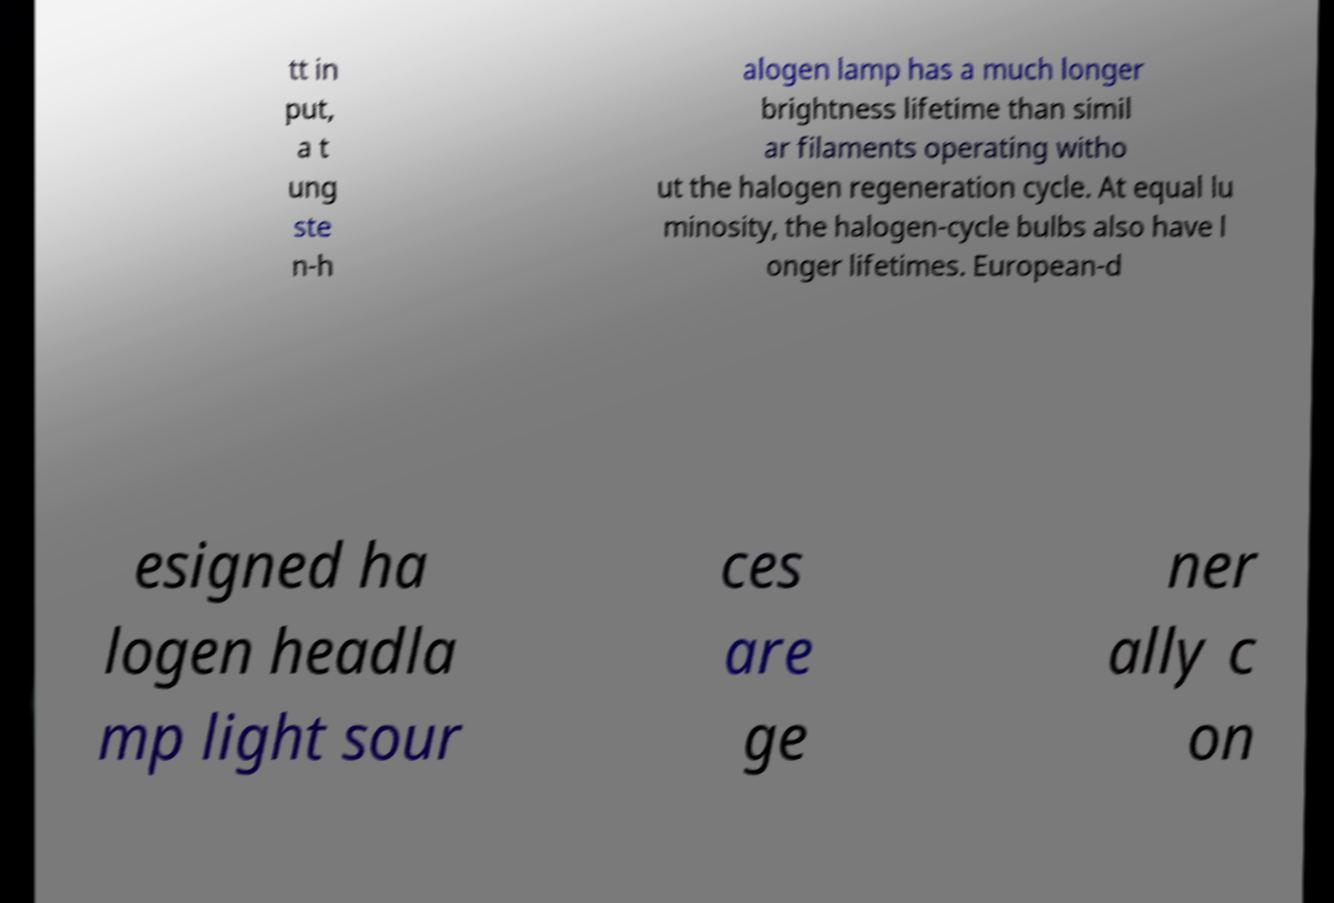I need the written content from this picture converted into text. Can you do that? tt in put, a t ung ste n-h alogen lamp has a much longer brightness lifetime than simil ar filaments operating witho ut the halogen regeneration cycle. At equal lu minosity, the halogen-cycle bulbs also have l onger lifetimes. European-d esigned ha logen headla mp light sour ces are ge ner ally c on 